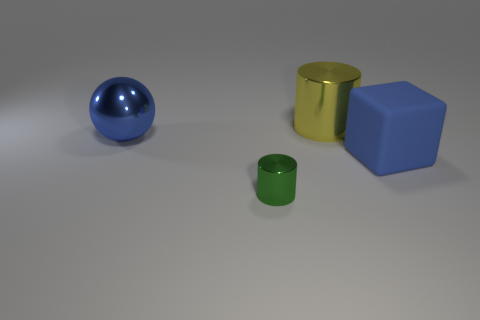Is there a big blue cylinder?
Keep it short and to the point. No. What is the material of the blue thing that is right of the thing in front of the large thing in front of the ball?
Provide a succinct answer. Rubber. Do the blue metal thing and the object that is behind the metal ball have the same shape?
Give a very brief answer. No. What number of brown things are the same shape as the green shiny object?
Your answer should be compact. 0. What shape is the green thing?
Ensure brevity in your answer.  Cylinder. How big is the metal cylinder on the right side of the cylinder that is on the left side of the yellow object?
Provide a succinct answer. Large. How many objects are either big yellow objects or rubber objects?
Ensure brevity in your answer.  2. Is the shape of the green thing the same as the yellow thing?
Provide a succinct answer. Yes. Is there a blue thing made of the same material as the big yellow thing?
Provide a succinct answer. Yes. There is a large metal object to the right of the blue ball; are there any objects in front of it?
Make the answer very short. Yes. 